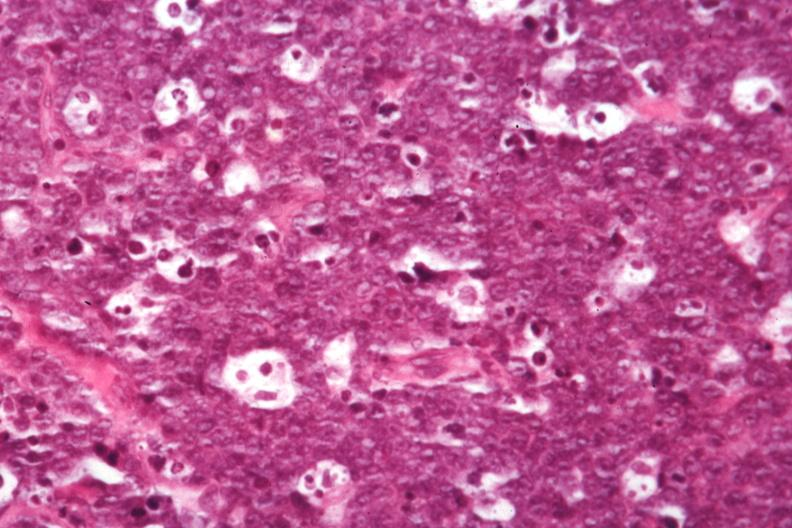what is present?
Answer the question using a single word or phrase. Lymph node 